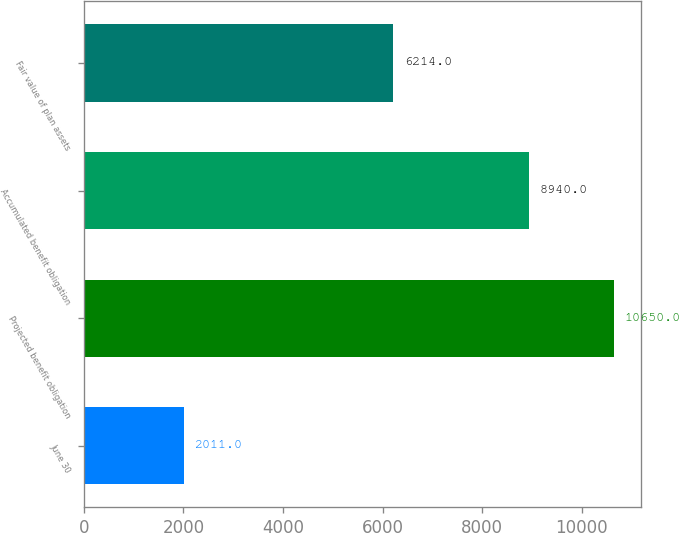<chart> <loc_0><loc_0><loc_500><loc_500><bar_chart><fcel>June 30<fcel>Projected benefit obligation<fcel>Accumulated benefit obligation<fcel>Fair value of plan assets<nl><fcel>2011<fcel>10650<fcel>8940<fcel>6214<nl></chart> 